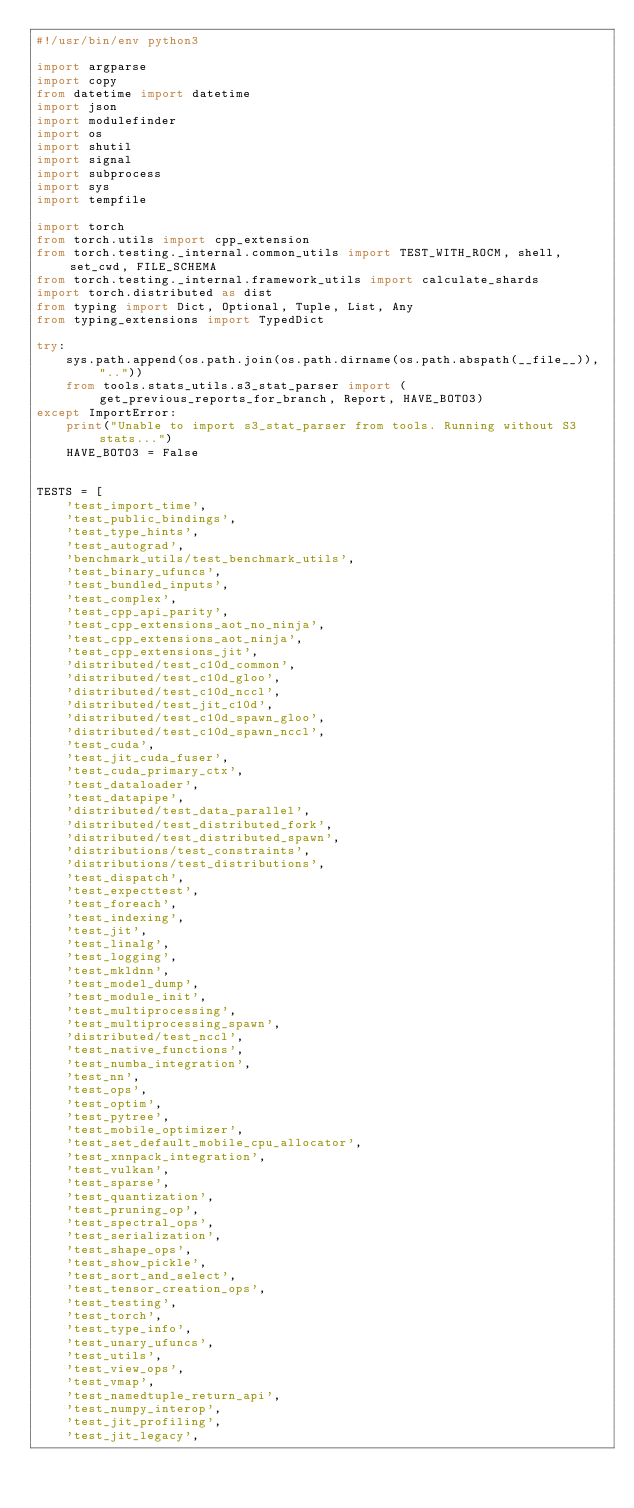<code> <loc_0><loc_0><loc_500><loc_500><_Python_>#!/usr/bin/env python3

import argparse
import copy
from datetime import datetime
import json
import modulefinder
import os
import shutil
import signal
import subprocess
import sys
import tempfile

import torch
from torch.utils import cpp_extension
from torch.testing._internal.common_utils import TEST_WITH_ROCM, shell, set_cwd, FILE_SCHEMA
from torch.testing._internal.framework_utils import calculate_shards
import torch.distributed as dist
from typing import Dict, Optional, Tuple, List, Any
from typing_extensions import TypedDict

try:
    sys.path.append(os.path.join(os.path.dirname(os.path.abspath(__file__)), ".."))
    from tools.stats_utils.s3_stat_parser import (get_previous_reports_for_branch, Report, HAVE_BOTO3)
except ImportError:
    print("Unable to import s3_stat_parser from tools. Running without S3 stats...")
    HAVE_BOTO3 = False


TESTS = [
    'test_import_time',
    'test_public_bindings',
    'test_type_hints',
    'test_autograd',
    'benchmark_utils/test_benchmark_utils',
    'test_binary_ufuncs',
    'test_bundled_inputs',
    'test_complex',
    'test_cpp_api_parity',
    'test_cpp_extensions_aot_no_ninja',
    'test_cpp_extensions_aot_ninja',
    'test_cpp_extensions_jit',
    'distributed/test_c10d_common',
    'distributed/test_c10d_gloo',
    'distributed/test_c10d_nccl',
    'distributed/test_jit_c10d',
    'distributed/test_c10d_spawn_gloo',
    'distributed/test_c10d_spawn_nccl',
    'test_cuda',
    'test_jit_cuda_fuser',
    'test_cuda_primary_ctx',
    'test_dataloader',
    'test_datapipe',
    'distributed/test_data_parallel',
    'distributed/test_distributed_fork',
    'distributed/test_distributed_spawn',
    'distributions/test_constraints',
    'distributions/test_distributions',
    'test_dispatch',
    'test_expecttest',
    'test_foreach',
    'test_indexing',
    'test_jit',
    'test_linalg',
    'test_logging',
    'test_mkldnn',
    'test_model_dump',
    'test_module_init',
    'test_multiprocessing',
    'test_multiprocessing_spawn',
    'distributed/test_nccl',
    'test_native_functions',
    'test_numba_integration',
    'test_nn',
    'test_ops',
    'test_optim',
    'test_pytree',
    'test_mobile_optimizer',
    'test_set_default_mobile_cpu_allocator',
    'test_xnnpack_integration',
    'test_vulkan',
    'test_sparse',
    'test_quantization',
    'test_pruning_op',
    'test_spectral_ops',
    'test_serialization',
    'test_shape_ops',
    'test_show_pickle',
    'test_sort_and_select',
    'test_tensor_creation_ops',
    'test_testing',
    'test_torch',
    'test_type_info',
    'test_unary_ufuncs',
    'test_utils',
    'test_view_ops',
    'test_vmap',
    'test_namedtuple_return_api',
    'test_numpy_interop',
    'test_jit_profiling',
    'test_jit_legacy',</code> 